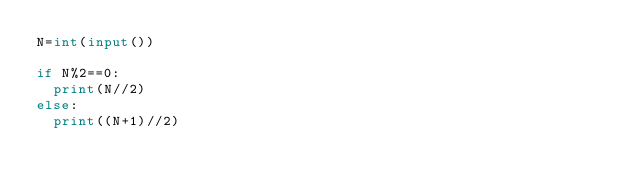Convert code to text. <code><loc_0><loc_0><loc_500><loc_500><_Python_>N=int(input())

if N%2==0:
  print(N//2)
else:
  print((N+1)//2)</code> 